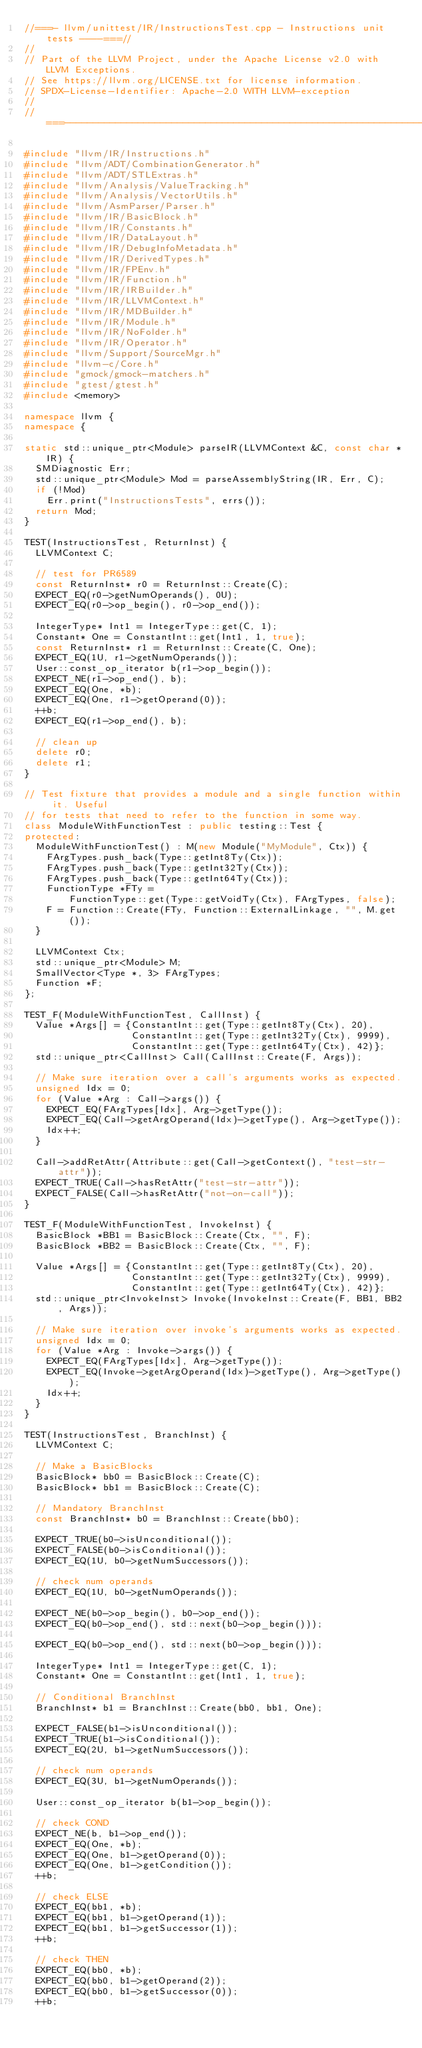<code> <loc_0><loc_0><loc_500><loc_500><_C++_>//===- llvm/unittest/IR/InstructionsTest.cpp - Instructions unit tests ----===//
//
// Part of the LLVM Project, under the Apache License v2.0 with LLVM Exceptions.
// See https://llvm.org/LICENSE.txt for license information.
// SPDX-License-Identifier: Apache-2.0 WITH LLVM-exception
//
//===----------------------------------------------------------------------===//

#include "llvm/IR/Instructions.h"
#include "llvm/ADT/CombinationGenerator.h"
#include "llvm/ADT/STLExtras.h"
#include "llvm/Analysis/ValueTracking.h"
#include "llvm/Analysis/VectorUtils.h"
#include "llvm/AsmParser/Parser.h"
#include "llvm/IR/BasicBlock.h"
#include "llvm/IR/Constants.h"
#include "llvm/IR/DataLayout.h"
#include "llvm/IR/DebugInfoMetadata.h"
#include "llvm/IR/DerivedTypes.h"
#include "llvm/IR/FPEnv.h"
#include "llvm/IR/Function.h"
#include "llvm/IR/IRBuilder.h"
#include "llvm/IR/LLVMContext.h"
#include "llvm/IR/MDBuilder.h"
#include "llvm/IR/Module.h"
#include "llvm/IR/NoFolder.h"
#include "llvm/IR/Operator.h"
#include "llvm/Support/SourceMgr.h"
#include "llvm-c/Core.h"
#include "gmock/gmock-matchers.h"
#include "gtest/gtest.h"
#include <memory>

namespace llvm {
namespace {

static std::unique_ptr<Module> parseIR(LLVMContext &C, const char *IR) {
  SMDiagnostic Err;
  std::unique_ptr<Module> Mod = parseAssemblyString(IR, Err, C);
  if (!Mod)
    Err.print("InstructionsTests", errs());
  return Mod;
}

TEST(InstructionsTest, ReturnInst) {
  LLVMContext C;

  // test for PR6589
  const ReturnInst* r0 = ReturnInst::Create(C);
  EXPECT_EQ(r0->getNumOperands(), 0U);
  EXPECT_EQ(r0->op_begin(), r0->op_end());

  IntegerType* Int1 = IntegerType::get(C, 1);
  Constant* One = ConstantInt::get(Int1, 1, true);
  const ReturnInst* r1 = ReturnInst::Create(C, One);
  EXPECT_EQ(1U, r1->getNumOperands());
  User::const_op_iterator b(r1->op_begin());
  EXPECT_NE(r1->op_end(), b);
  EXPECT_EQ(One, *b);
  EXPECT_EQ(One, r1->getOperand(0));
  ++b;
  EXPECT_EQ(r1->op_end(), b);

  // clean up
  delete r0;
  delete r1;
}

// Test fixture that provides a module and a single function within it. Useful
// for tests that need to refer to the function in some way.
class ModuleWithFunctionTest : public testing::Test {
protected:
  ModuleWithFunctionTest() : M(new Module("MyModule", Ctx)) {
    FArgTypes.push_back(Type::getInt8Ty(Ctx));
    FArgTypes.push_back(Type::getInt32Ty(Ctx));
    FArgTypes.push_back(Type::getInt64Ty(Ctx));
    FunctionType *FTy =
        FunctionType::get(Type::getVoidTy(Ctx), FArgTypes, false);
    F = Function::Create(FTy, Function::ExternalLinkage, "", M.get());
  }

  LLVMContext Ctx;
  std::unique_ptr<Module> M;
  SmallVector<Type *, 3> FArgTypes;
  Function *F;
};

TEST_F(ModuleWithFunctionTest, CallInst) {
  Value *Args[] = {ConstantInt::get(Type::getInt8Ty(Ctx), 20),
                   ConstantInt::get(Type::getInt32Ty(Ctx), 9999),
                   ConstantInt::get(Type::getInt64Ty(Ctx), 42)};
  std::unique_ptr<CallInst> Call(CallInst::Create(F, Args));

  // Make sure iteration over a call's arguments works as expected.
  unsigned Idx = 0;
  for (Value *Arg : Call->args()) {
    EXPECT_EQ(FArgTypes[Idx], Arg->getType());
    EXPECT_EQ(Call->getArgOperand(Idx)->getType(), Arg->getType());
    Idx++;
  }

  Call->addRetAttr(Attribute::get(Call->getContext(), "test-str-attr"));
  EXPECT_TRUE(Call->hasRetAttr("test-str-attr"));
  EXPECT_FALSE(Call->hasRetAttr("not-on-call"));
}

TEST_F(ModuleWithFunctionTest, InvokeInst) {
  BasicBlock *BB1 = BasicBlock::Create(Ctx, "", F);
  BasicBlock *BB2 = BasicBlock::Create(Ctx, "", F);

  Value *Args[] = {ConstantInt::get(Type::getInt8Ty(Ctx), 20),
                   ConstantInt::get(Type::getInt32Ty(Ctx), 9999),
                   ConstantInt::get(Type::getInt64Ty(Ctx), 42)};
  std::unique_ptr<InvokeInst> Invoke(InvokeInst::Create(F, BB1, BB2, Args));

  // Make sure iteration over invoke's arguments works as expected.
  unsigned Idx = 0;
  for (Value *Arg : Invoke->args()) {
    EXPECT_EQ(FArgTypes[Idx], Arg->getType());
    EXPECT_EQ(Invoke->getArgOperand(Idx)->getType(), Arg->getType());
    Idx++;
  }
}

TEST(InstructionsTest, BranchInst) {
  LLVMContext C;

  // Make a BasicBlocks
  BasicBlock* bb0 = BasicBlock::Create(C);
  BasicBlock* bb1 = BasicBlock::Create(C);

  // Mandatory BranchInst
  const BranchInst* b0 = BranchInst::Create(bb0);

  EXPECT_TRUE(b0->isUnconditional());
  EXPECT_FALSE(b0->isConditional());
  EXPECT_EQ(1U, b0->getNumSuccessors());

  // check num operands
  EXPECT_EQ(1U, b0->getNumOperands());

  EXPECT_NE(b0->op_begin(), b0->op_end());
  EXPECT_EQ(b0->op_end(), std::next(b0->op_begin()));

  EXPECT_EQ(b0->op_end(), std::next(b0->op_begin()));

  IntegerType* Int1 = IntegerType::get(C, 1);
  Constant* One = ConstantInt::get(Int1, 1, true);

  // Conditional BranchInst
  BranchInst* b1 = BranchInst::Create(bb0, bb1, One);

  EXPECT_FALSE(b1->isUnconditional());
  EXPECT_TRUE(b1->isConditional());
  EXPECT_EQ(2U, b1->getNumSuccessors());

  // check num operands
  EXPECT_EQ(3U, b1->getNumOperands());

  User::const_op_iterator b(b1->op_begin());

  // check COND
  EXPECT_NE(b, b1->op_end());
  EXPECT_EQ(One, *b);
  EXPECT_EQ(One, b1->getOperand(0));
  EXPECT_EQ(One, b1->getCondition());
  ++b;

  // check ELSE
  EXPECT_EQ(bb1, *b);
  EXPECT_EQ(bb1, b1->getOperand(1));
  EXPECT_EQ(bb1, b1->getSuccessor(1));
  ++b;

  // check THEN
  EXPECT_EQ(bb0, *b);
  EXPECT_EQ(bb0, b1->getOperand(2));
  EXPECT_EQ(bb0, b1->getSuccessor(0));
  ++b;
</code> 